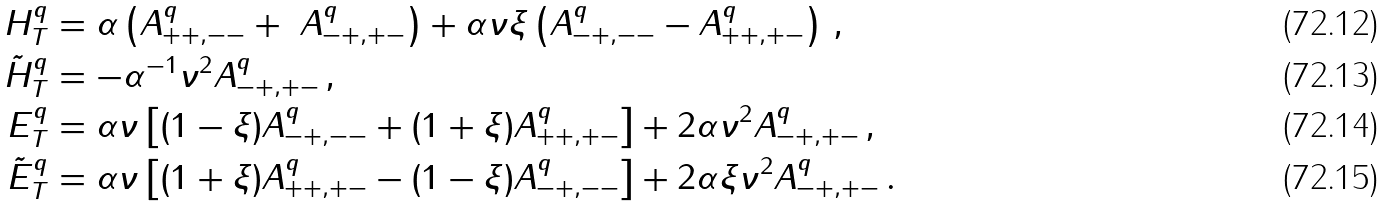<formula> <loc_0><loc_0><loc_500><loc_500>H _ { T } ^ { q } & = \alpha \left ( A _ { + + , - - } ^ { q } + \ A _ { - + , + - } ^ { q } \right ) + \alpha \nu \xi \left ( A _ { - + , - - } ^ { q } - A _ { + + , + - } ^ { q } \right ) \, , \\ \tilde { H } _ { T } ^ { q } & = - \alpha ^ { - 1 } \nu ^ { 2 } A _ { - + , + - } ^ { q } \, , \\ E _ { T } ^ { q } & = \alpha \nu \left [ ( 1 - \xi ) A _ { - + , - - } ^ { q } + ( 1 + \xi ) A _ { + + , + - } ^ { q } \right ] + 2 \alpha \nu ^ { 2 } A _ { - + , + - } ^ { q } \, , \\ \tilde { E } _ { T } ^ { q } & = \alpha \nu \left [ ( 1 + \xi ) A _ { + + , + - } ^ { q } - ( 1 - \xi ) A _ { - + , - - } ^ { q } \right ] + 2 \alpha \xi \nu ^ { 2 } A _ { - + , + - } ^ { q } \, .</formula> 